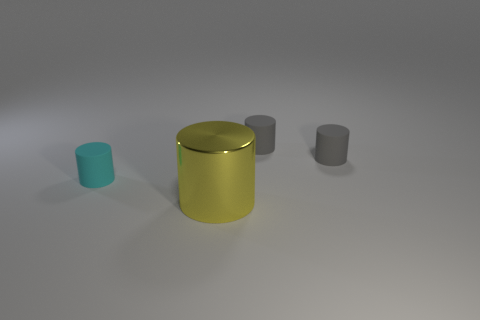What color is the cylinder in front of the thing on the left side of the big yellow metal thing?
Give a very brief answer. Yellow. Is there anything else that is the same size as the yellow cylinder?
Offer a very short reply. No. There is a thing that is in front of the cyan cylinder; is it the same shape as the small cyan thing?
Your answer should be very brief. Yes. How many cylinders are on the right side of the large yellow object and to the left of the large yellow thing?
Make the answer very short. 0. What is the color of the small thing that is on the left side of the cylinder in front of the tiny rubber object that is left of the yellow shiny cylinder?
Give a very brief answer. Cyan. There is a tiny cylinder left of the yellow cylinder; how many yellow cylinders are on the right side of it?
Your response must be concise. 1. How many other objects are there of the same shape as the metallic object?
Your answer should be compact. 3. How many objects are either tiny cyan shiny cylinders or tiny gray cylinders behind the big cylinder?
Provide a short and direct response. 2. Are there more big yellow metal cylinders that are in front of the big yellow shiny thing than tiny cylinders that are behind the small cyan thing?
Ensure brevity in your answer.  No. Are there any small things made of the same material as the cyan cylinder?
Offer a terse response. Yes. 